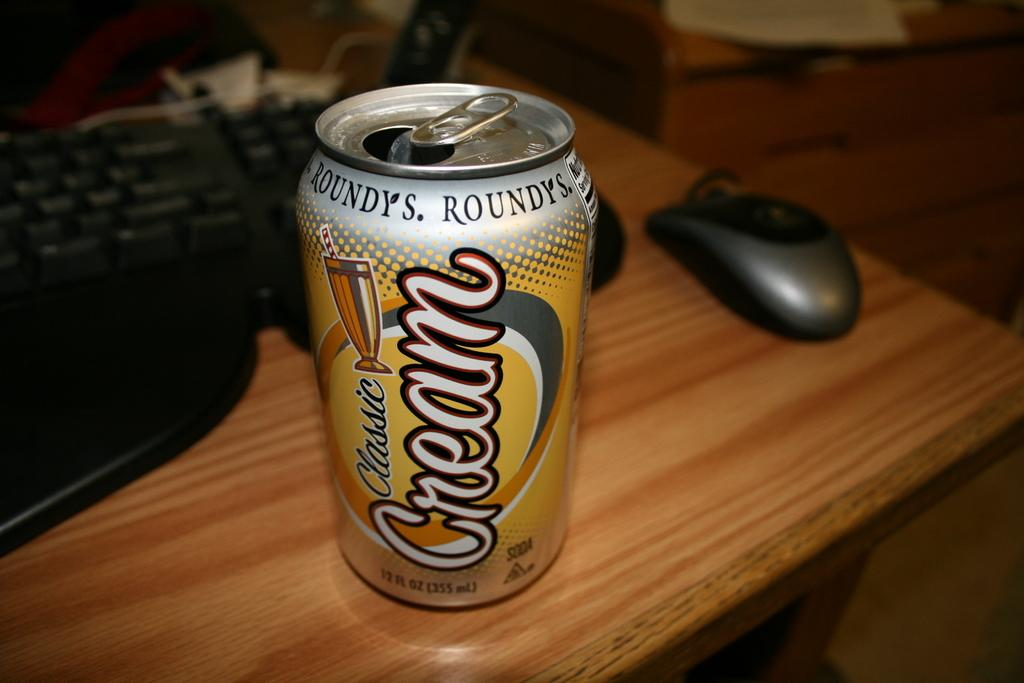<image>
Provide a brief description of the given image. Silver can that says the word Classic on it. 